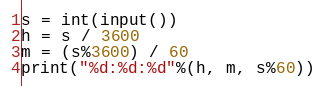Convert code to text. <code><loc_0><loc_0><loc_500><loc_500><_Python_>s = int(input())
h = s / 3600
m = (s%3600) / 60
print("%d:%d:%d"%(h, m, s%60))

</code> 